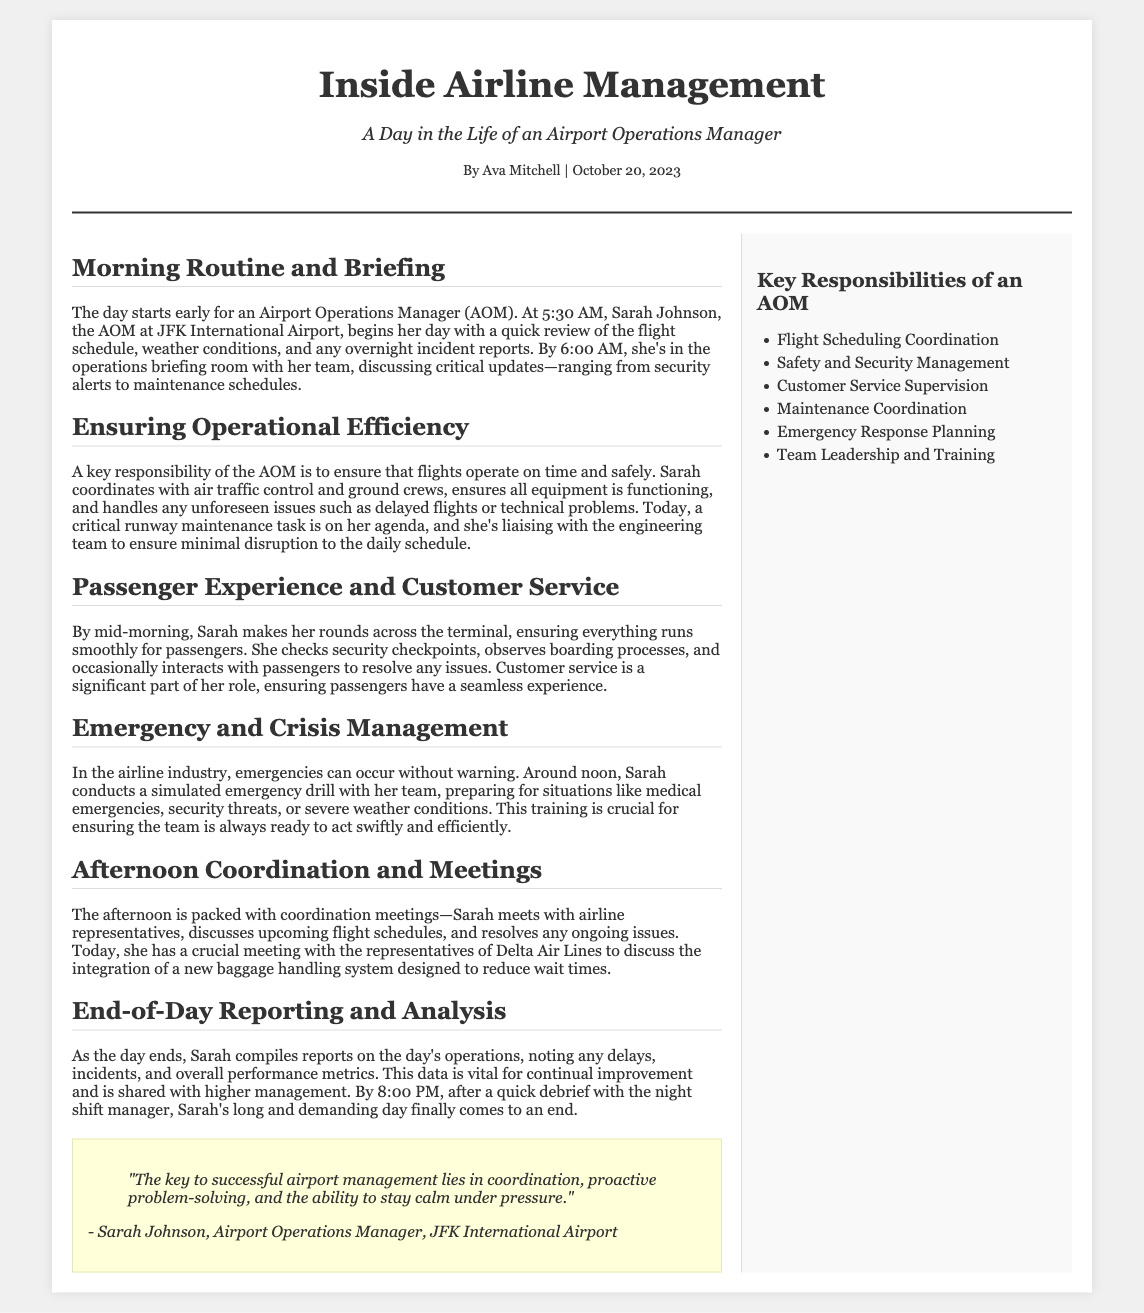What time does Sarah Johnson start her day? Sarah Johnson begins her day at 5:30 AM, as indicated in the document.
Answer: 5:30 AM What is one of Sarah's key responsibilities? The document mentions that a key responsibility of the AOM is to ensure flights operate on time and safely.
Answer: Ensure flights operate on time What type of drill does Sarah conduct around noon? The document states that around noon, Sarah conducts a simulated emergency drill.
Answer: Simulated emergency drill What is discussed in the afternoon meetings? In the afternoon meetings, Sarah discusses upcoming flight schedules and resolves ongoing issues.
Answer: Upcoming flight schedules Who is Sarah's crucial meeting with today? The document specifies that Sarah has a crucial meeting with the representatives of Delta Air Lines.
Answer: Representatives of Delta Air Lines What does Sarah compile at the end of the day? Sarah compiles reports on the day's operations, including noting any delays and incidents.
Answer: Reports on the day's operations What is a significant part of Sarah's role? The document emphasizes that customer service is a significant part of Sarah's role.
Answer: Customer service What does Sarah ensure is functioning? The document mentions that Sarah ensures all equipment is functioning.
Answer: All equipment What is the title of the article? The title of the article is shown at the top of the document.
Answer: Inside Airline Management 